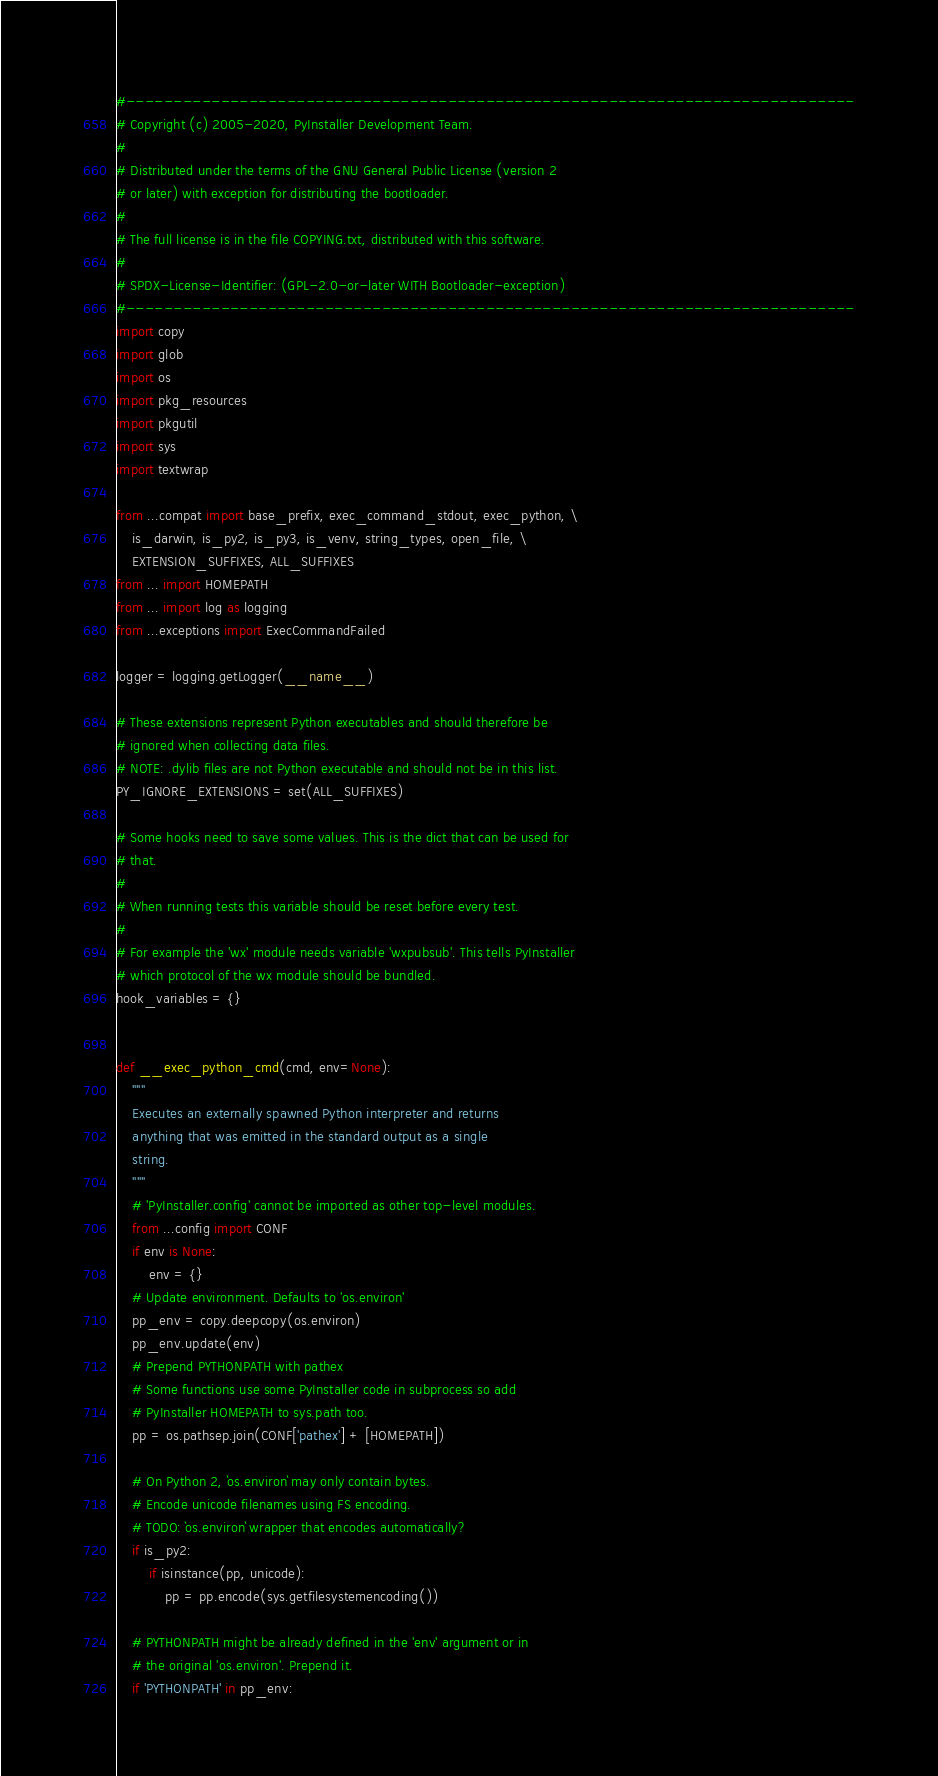Convert code to text. <code><loc_0><loc_0><loc_500><loc_500><_Python_>#-----------------------------------------------------------------------------
# Copyright (c) 2005-2020, PyInstaller Development Team.
#
# Distributed under the terms of the GNU General Public License (version 2
# or later) with exception for distributing the bootloader.
#
# The full license is in the file COPYING.txt, distributed with this software.
#
# SPDX-License-Identifier: (GPL-2.0-or-later WITH Bootloader-exception)
#-----------------------------------------------------------------------------
import copy
import glob
import os
import pkg_resources
import pkgutil
import sys
import textwrap

from ...compat import base_prefix, exec_command_stdout, exec_python, \
    is_darwin, is_py2, is_py3, is_venv, string_types, open_file, \
    EXTENSION_SUFFIXES, ALL_SUFFIXES
from ... import HOMEPATH
from ... import log as logging
from ...exceptions import ExecCommandFailed

logger = logging.getLogger(__name__)

# These extensions represent Python executables and should therefore be
# ignored when collecting data files.
# NOTE: .dylib files are not Python executable and should not be in this list.
PY_IGNORE_EXTENSIONS = set(ALL_SUFFIXES)

# Some hooks need to save some values. This is the dict that can be used for
# that.
#
# When running tests this variable should be reset before every test.
#
# For example the 'wx' module needs variable 'wxpubsub'. This tells PyInstaller
# which protocol of the wx module should be bundled.
hook_variables = {}


def __exec_python_cmd(cmd, env=None):
    """
    Executes an externally spawned Python interpreter and returns
    anything that was emitted in the standard output as a single
    string.
    """
    # 'PyInstaller.config' cannot be imported as other top-level modules.
    from ...config import CONF
    if env is None:
        env = {}
    # Update environment. Defaults to 'os.environ'
    pp_env = copy.deepcopy(os.environ)
    pp_env.update(env)
    # Prepend PYTHONPATH with pathex
    # Some functions use some PyInstaller code in subprocess so add
    # PyInstaller HOMEPATH to sys.path too.
    pp = os.pathsep.join(CONF['pathex'] + [HOMEPATH])

    # On Python 2, `os.environ` may only contain bytes.
    # Encode unicode filenames using FS encoding.
    # TODO: `os.environ` wrapper that encodes automatically?
    if is_py2:
        if isinstance(pp, unicode):
            pp = pp.encode(sys.getfilesystemencoding())

    # PYTHONPATH might be already defined in the 'env' argument or in
    # the original 'os.environ'. Prepend it.
    if 'PYTHONPATH' in pp_env:</code> 